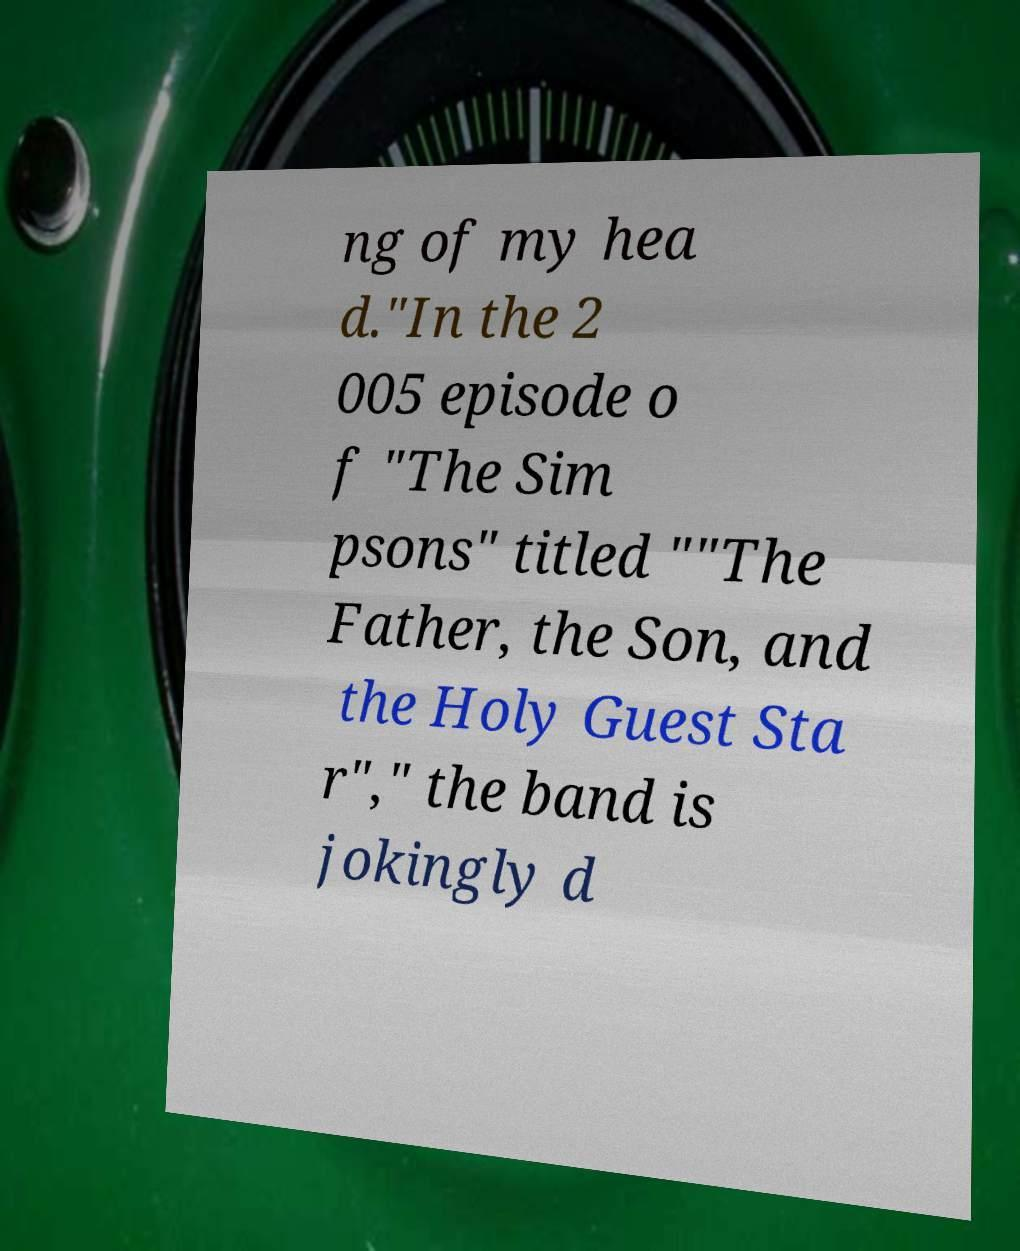Could you assist in decoding the text presented in this image and type it out clearly? ng of my hea d."In the 2 005 episode o f "The Sim psons" titled ""The Father, the Son, and the Holy Guest Sta r"," the band is jokingly d 